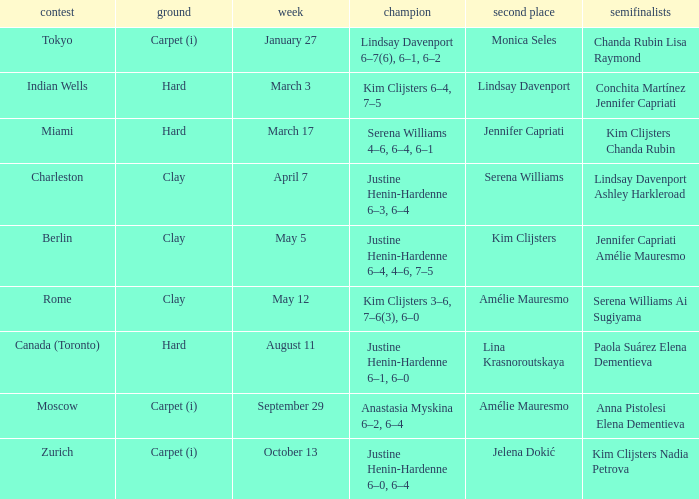Can you parse all the data within this table? {'header': ['contest', 'ground', 'week', 'champion', 'second place', 'semifinalists'], 'rows': [['Tokyo', 'Carpet (i)', 'January 27', 'Lindsay Davenport 6–7(6), 6–1, 6–2', 'Monica Seles', 'Chanda Rubin Lisa Raymond'], ['Indian Wells', 'Hard', 'March 3', 'Kim Clijsters 6–4, 7–5', 'Lindsay Davenport', 'Conchita Martínez Jennifer Capriati'], ['Miami', 'Hard', 'March 17', 'Serena Williams 4–6, 6–4, 6–1', 'Jennifer Capriati', 'Kim Clijsters Chanda Rubin'], ['Charleston', 'Clay', 'April 7', 'Justine Henin-Hardenne 6–3, 6–4', 'Serena Williams', 'Lindsay Davenport Ashley Harkleroad'], ['Berlin', 'Clay', 'May 5', 'Justine Henin-Hardenne 6–4, 4–6, 7–5', 'Kim Clijsters', 'Jennifer Capriati Amélie Mauresmo'], ['Rome', 'Clay', 'May 12', 'Kim Clijsters 3–6, 7–6(3), 6–0', 'Amélie Mauresmo', 'Serena Williams Ai Sugiyama'], ['Canada (Toronto)', 'Hard', 'August 11', 'Justine Henin-Hardenne 6–1, 6–0', 'Lina Krasnoroutskaya', 'Paola Suárez Elena Dementieva'], ['Moscow', 'Carpet (i)', 'September 29', 'Anastasia Myskina 6–2, 6–4', 'Amélie Mauresmo', 'Anna Pistolesi Elena Dementieva'], ['Zurich', 'Carpet (i)', 'October 13', 'Justine Henin-Hardenne 6–0, 6–4', 'Jelena Dokić', 'Kim Clijsters Nadia Petrova']]} Who was the winner against Lindsay Davenport? Kim Clijsters 6–4, 7–5. 